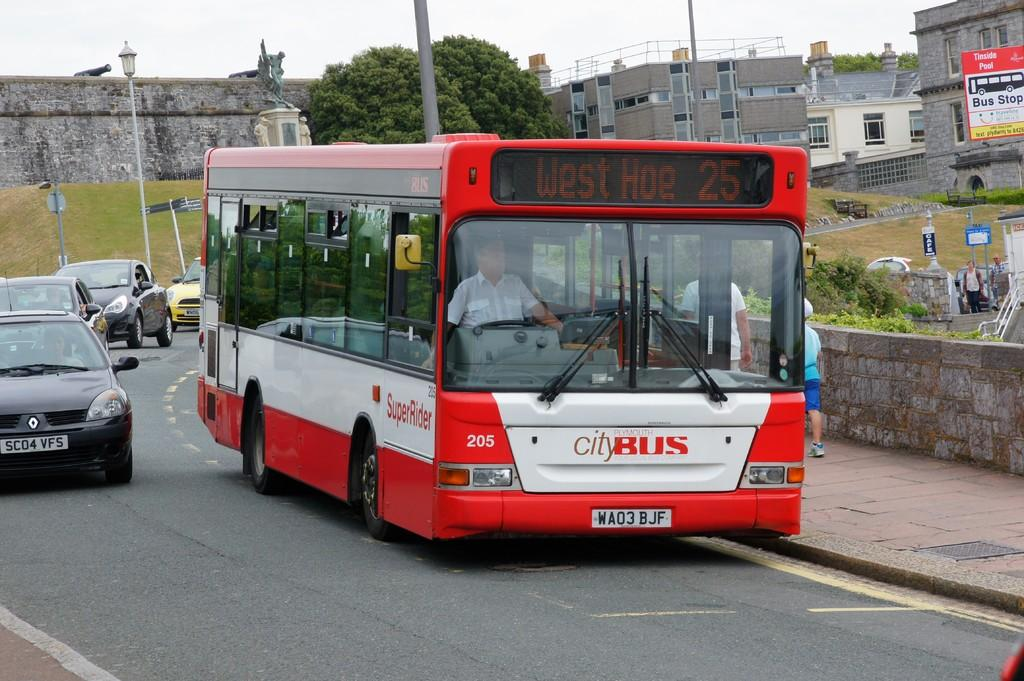Provide a one-sentence caption for the provided image. a red city bus that headlines west hoe 25. 